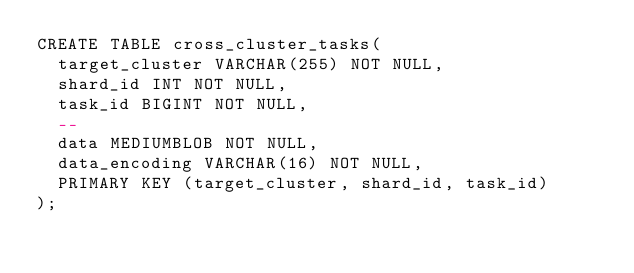<code> <loc_0><loc_0><loc_500><loc_500><_SQL_>CREATE TABLE cross_cluster_tasks(
  target_cluster VARCHAR(255) NOT NULL,
  shard_id INT NOT NULL,
  task_id BIGINT NOT NULL,
  --
  data MEDIUMBLOB NOT NULL,
  data_encoding VARCHAR(16) NOT NULL,
  PRIMARY KEY (target_cluster, shard_id, task_id)
);</code> 